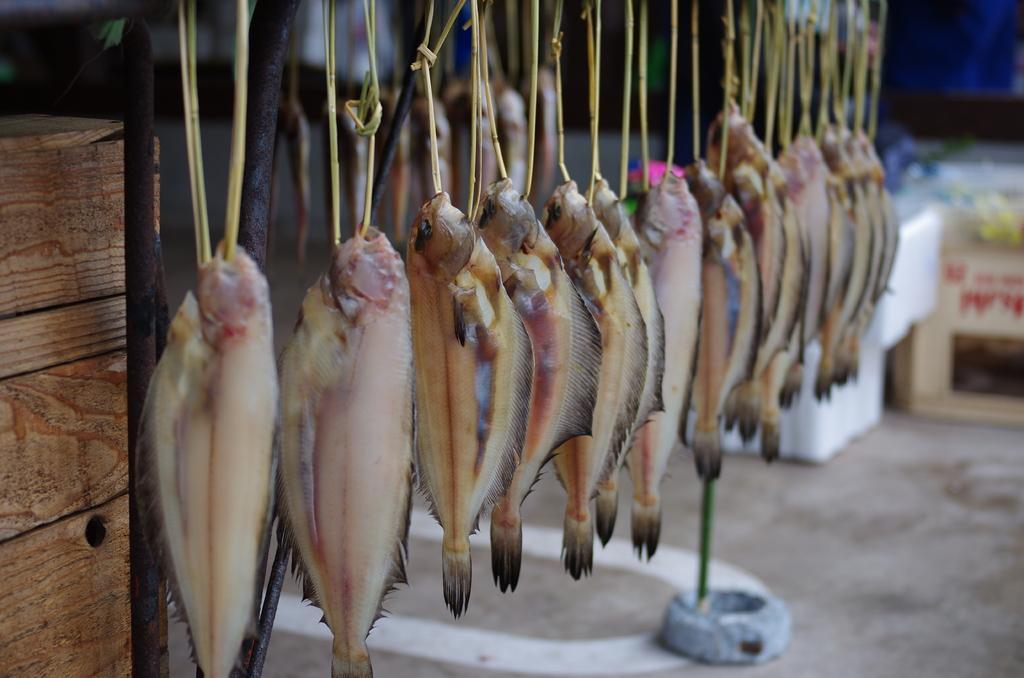Can you describe this image briefly? In this image there are fishes hanged to an object, there is a wooden object towards the left of the image, there are metal object, there is ground towards the bottom of the image, there is are objects on the ground, there is an object towards the right of the image that looks like a box, there is text on the box, the background of the image is dark. 